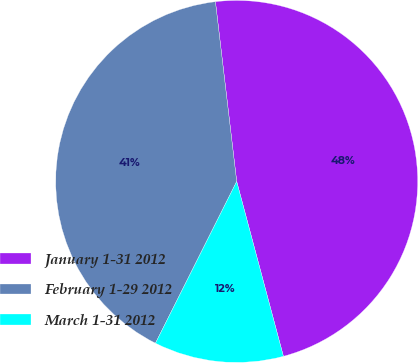Convert chart to OTSL. <chart><loc_0><loc_0><loc_500><loc_500><pie_chart><fcel>January 1-31 2012<fcel>February 1-29 2012<fcel>March 1-31 2012<nl><fcel>47.72%<fcel>40.72%<fcel>11.56%<nl></chart> 